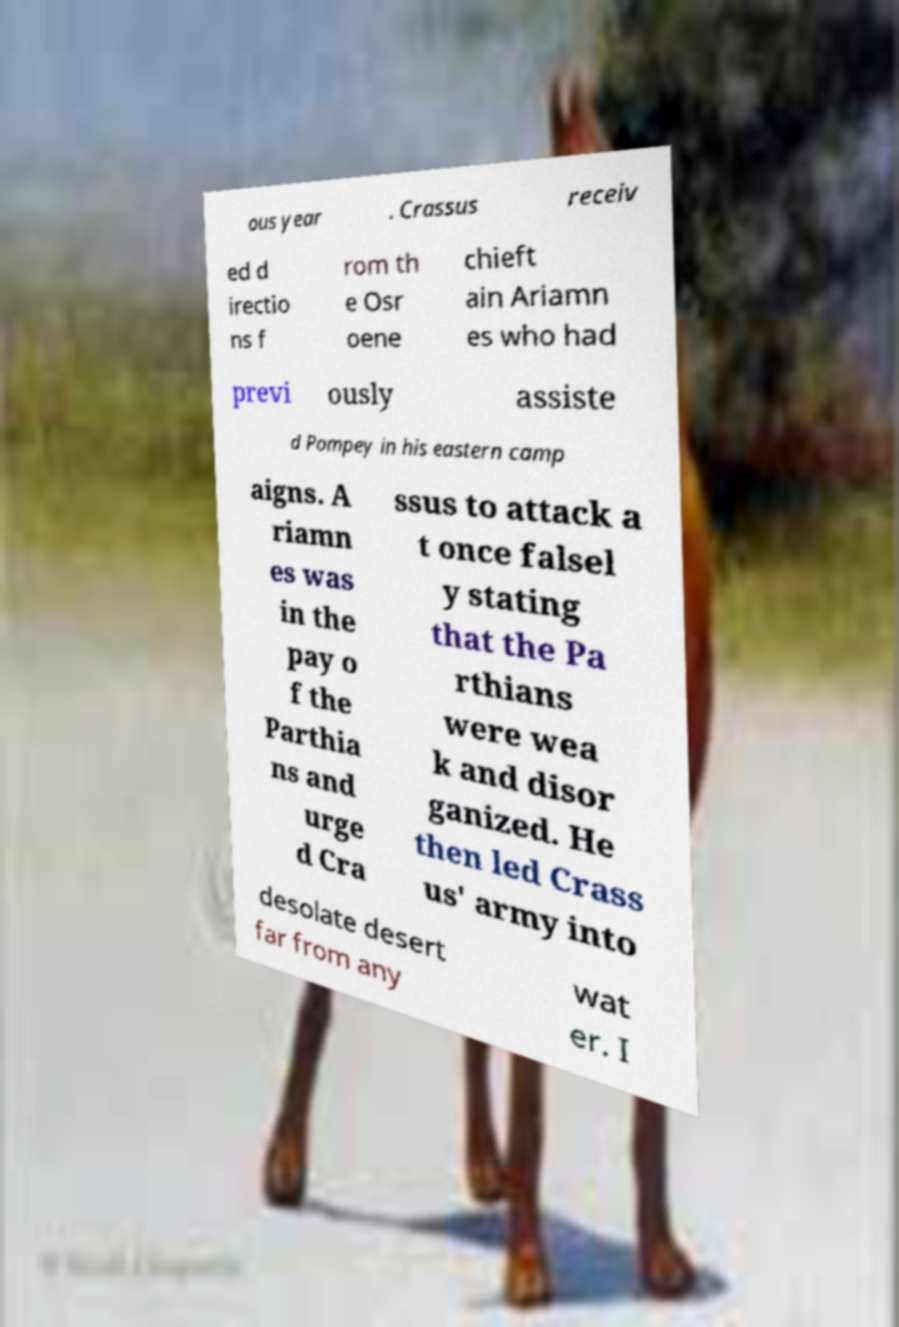There's text embedded in this image that I need extracted. Can you transcribe it verbatim? ous year . Crassus receiv ed d irectio ns f rom th e Osr oene chieft ain Ariamn es who had previ ously assiste d Pompey in his eastern camp aigns. A riamn es was in the pay o f the Parthia ns and urge d Cra ssus to attack a t once falsel y stating that the Pa rthians were wea k and disor ganized. He then led Crass us' army into desolate desert far from any wat er. I 